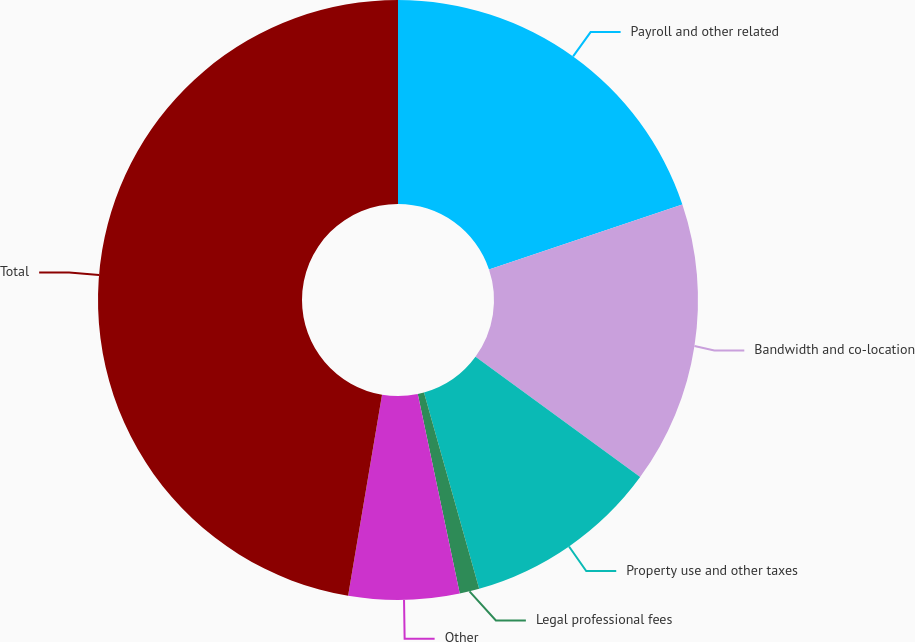Convert chart to OTSL. <chart><loc_0><loc_0><loc_500><loc_500><pie_chart><fcel>Payroll and other related<fcel>Bandwidth and co-location<fcel>Property use and other taxes<fcel>Legal professional fees<fcel>Other<fcel>Total<nl><fcel>19.84%<fcel>15.21%<fcel>10.59%<fcel>1.06%<fcel>5.96%<fcel>47.34%<nl></chart> 